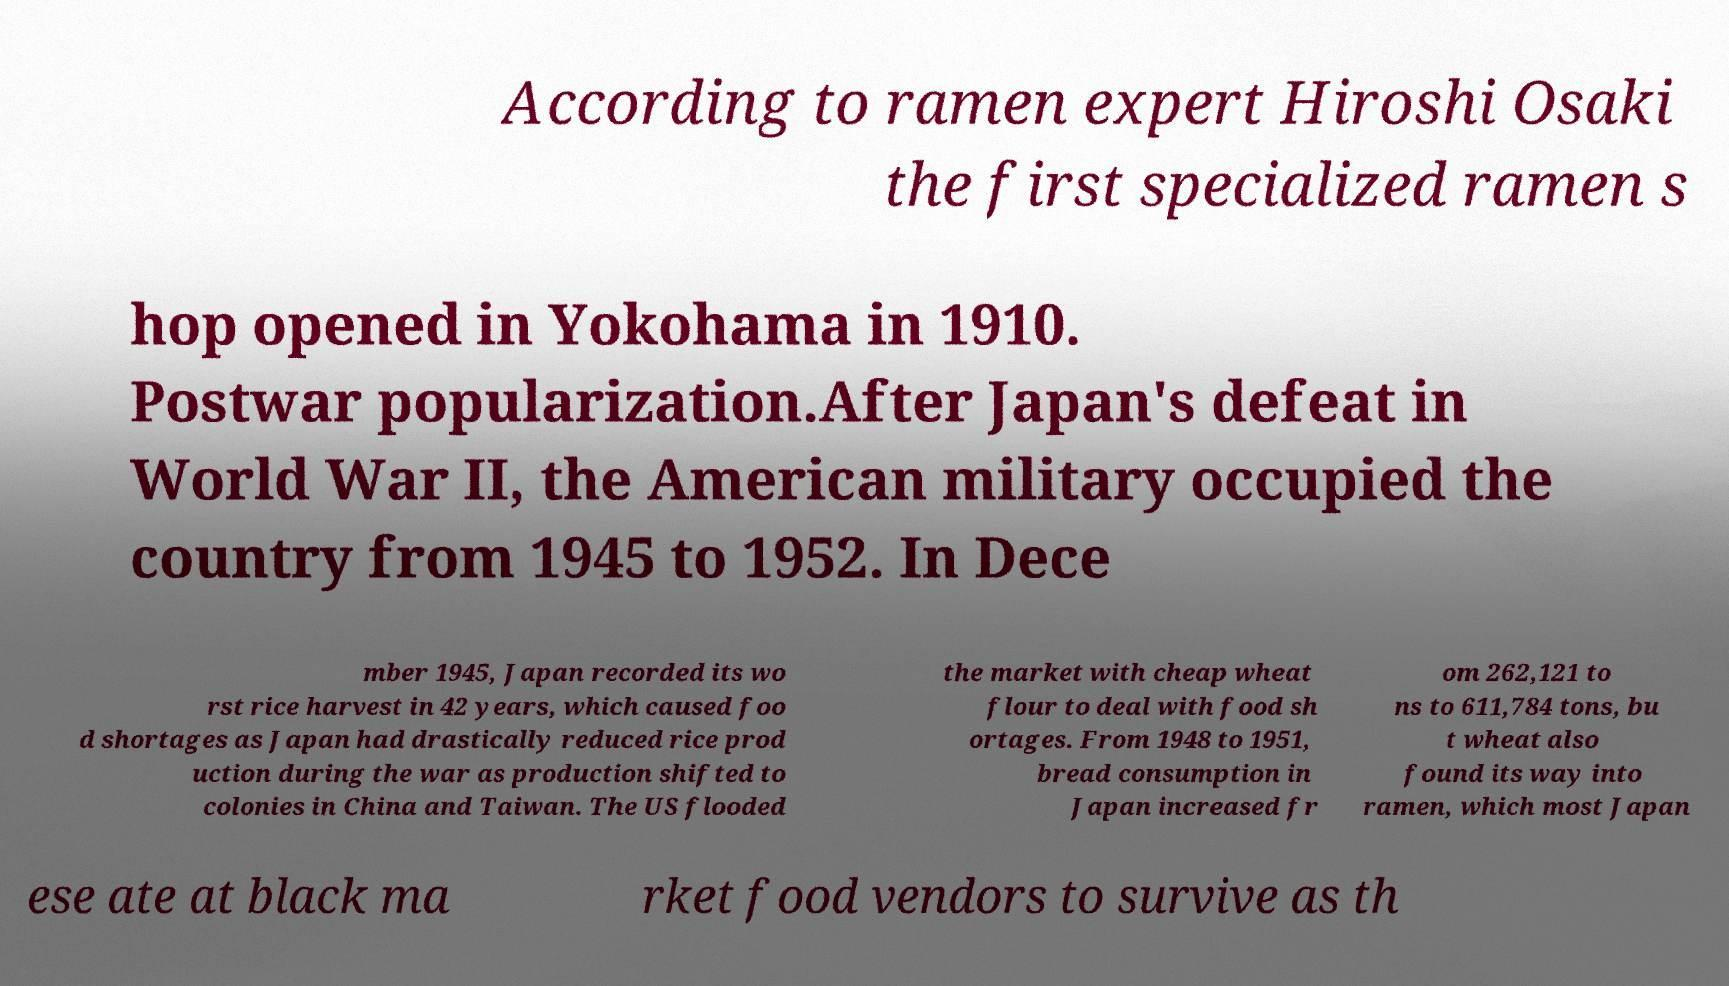For documentation purposes, I need the text within this image transcribed. Could you provide that? According to ramen expert Hiroshi Osaki the first specialized ramen s hop opened in Yokohama in 1910. Postwar popularization.After Japan's defeat in World War II, the American military occupied the country from 1945 to 1952. In Dece mber 1945, Japan recorded its wo rst rice harvest in 42 years, which caused foo d shortages as Japan had drastically reduced rice prod uction during the war as production shifted to colonies in China and Taiwan. The US flooded the market with cheap wheat flour to deal with food sh ortages. From 1948 to 1951, bread consumption in Japan increased fr om 262,121 to ns to 611,784 tons, bu t wheat also found its way into ramen, which most Japan ese ate at black ma rket food vendors to survive as th 